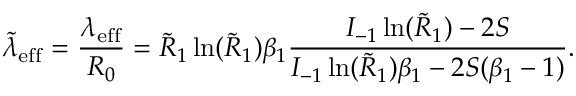Convert formula to latex. <formula><loc_0><loc_0><loc_500><loc_500>\tilde { \lambda } _ { e f f } = \frac { \lambda _ { e f f } } { R _ { 0 } } = \tilde { R } _ { 1 } \ln ( \tilde { R } _ { 1 } ) \beta _ { 1 } \frac { I _ { - 1 } \ln ( \tilde { R } _ { 1 } ) - 2 S } { I _ { - 1 } \ln ( \tilde { R } _ { 1 } ) \beta _ { 1 } - 2 S ( \beta _ { 1 } - 1 ) } .</formula> 